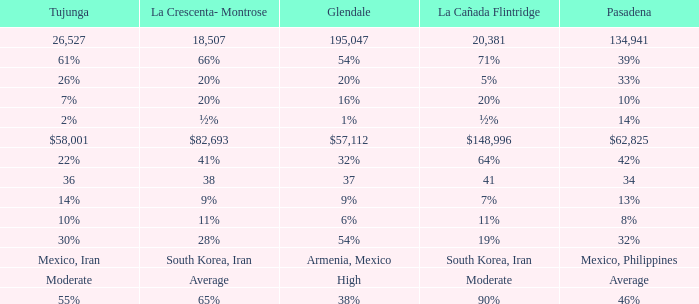What is the percentage of La Canada Flintridge when Tujunga is 7%? 20%. 